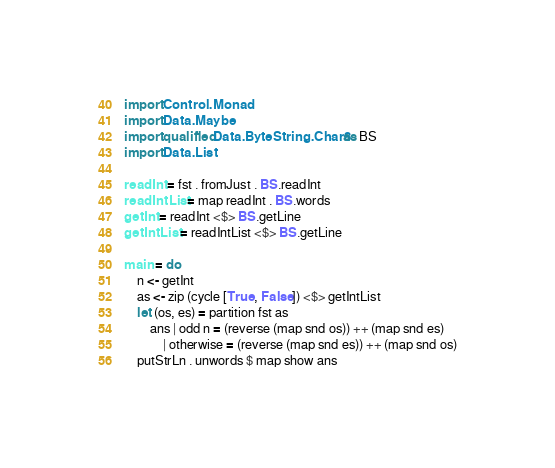Convert code to text. <code><loc_0><loc_0><loc_500><loc_500><_Haskell_>import Control.Monad
import Data.Maybe
import qualified Data.ByteString.Char8 as BS
import Data.List

readInt = fst . fromJust . BS.readInt
readIntList = map readInt . BS.words
getInt = readInt <$> BS.getLine
getIntList = readIntList <$> BS.getLine

main = do
    n <- getInt
    as <- zip (cycle [True, False]) <$> getIntList
    let (os, es) = partition fst as
        ans | odd n = (reverse (map snd os)) ++ (map snd es)
            | otherwise = (reverse (map snd es)) ++ (map snd os)
    putStrLn . unwords $ map show ans</code> 